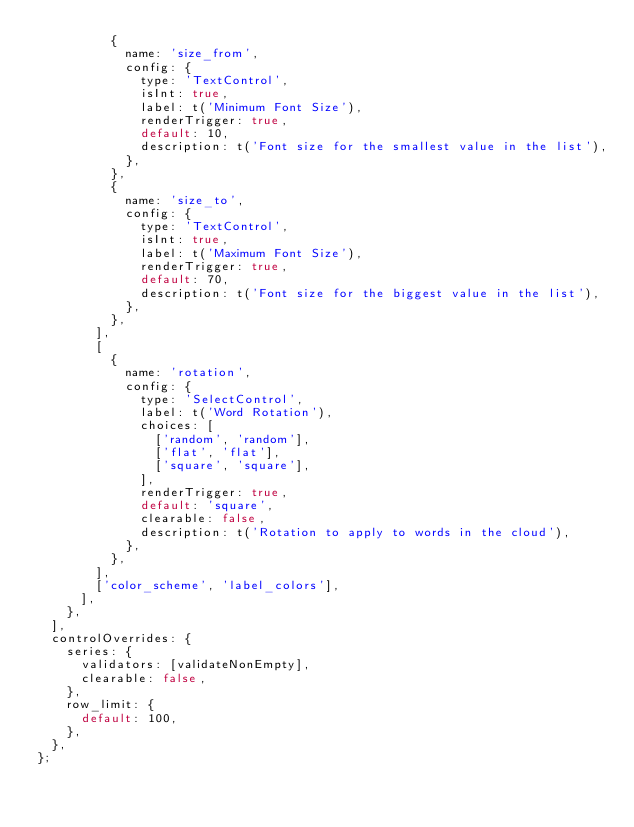Convert code to text. <code><loc_0><loc_0><loc_500><loc_500><_JavaScript_>          {
            name: 'size_from',
            config: {
              type: 'TextControl',
              isInt: true,
              label: t('Minimum Font Size'),
              renderTrigger: true,
              default: 10,
              description: t('Font size for the smallest value in the list'),
            },
          },
          {
            name: 'size_to',
            config: {
              type: 'TextControl',
              isInt: true,
              label: t('Maximum Font Size'),
              renderTrigger: true,
              default: 70,
              description: t('Font size for the biggest value in the list'),
            },
          },
        ],
        [
          {
            name: 'rotation',
            config: {
              type: 'SelectControl',
              label: t('Word Rotation'),
              choices: [
                ['random', 'random'],
                ['flat', 'flat'],
                ['square', 'square'],
              ],
              renderTrigger: true,
              default: 'square',
              clearable: false,
              description: t('Rotation to apply to words in the cloud'),
            },
          },
        ],
        ['color_scheme', 'label_colors'],
      ],
    },
  ],
  controlOverrides: {
    series: {
      validators: [validateNonEmpty],
      clearable: false,
    },
    row_limit: {
      default: 100,
    },
  },
};
</code> 